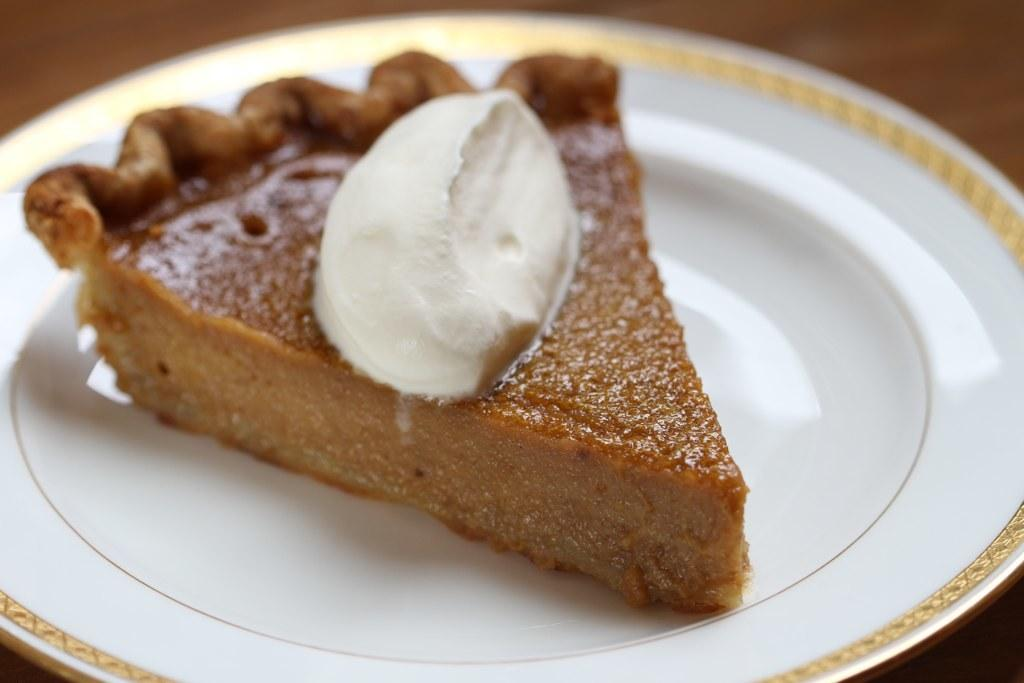What is present on the plate in the image? There is food in a plate in the image. Can you describe the object that the plate is placed on? Unfortunately, the facts provided do not give any information about the object the plate is placed on. What type of support is the stranger using to climb the zipper in the image? There is no stranger or zipper present in the image. 